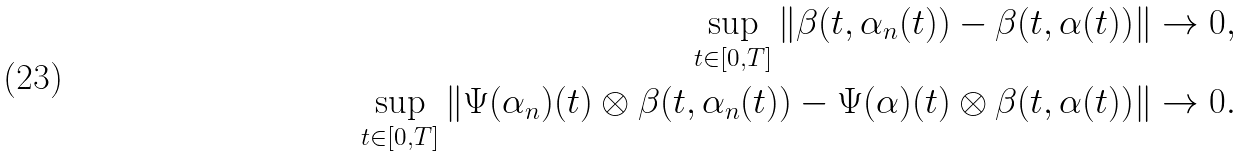Convert formula to latex. <formula><loc_0><loc_0><loc_500><loc_500>\sup _ { t \in [ 0 , T ] } \| \beta ( t , \alpha _ { n } ( t ) ) - \beta ( t , \alpha ( t ) ) \| \to 0 , \\ \sup _ { t \in [ 0 , T ] } \| \Psi ( \alpha _ { n } ) ( t ) \otimes \beta ( t , \alpha _ { n } ( t ) ) - \Psi ( \alpha ) ( t ) \otimes \beta ( t , \alpha ( t ) ) \| \to 0 .</formula> 